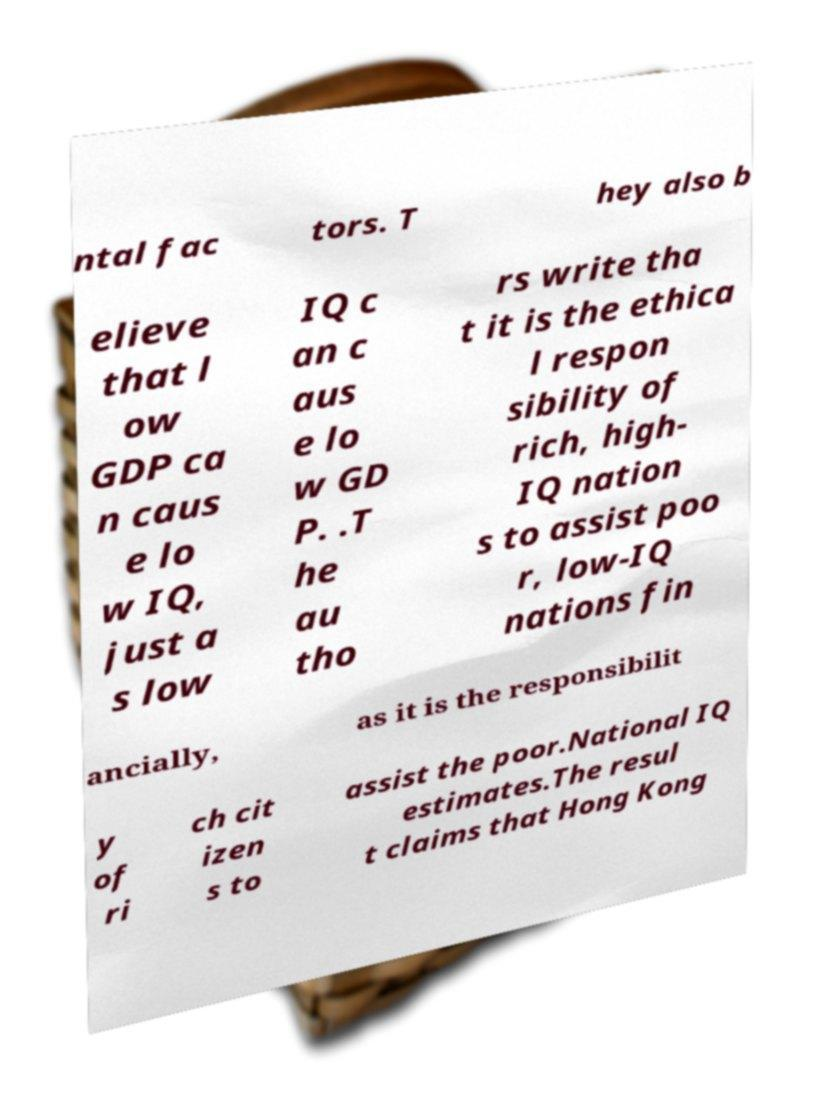Could you extract and type out the text from this image? ntal fac tors. T hey also b elieve that l ow GDP ca n caus e lo w IQ, just a s low IQ c an c aus e lo w GD P. .T he au tho rs write tha t it is the ethica l respon sibility of rich, high- IQ nation s to assist poo r, low-IQ nations fin ancially, as it is the responsibilit y of ri ch cit izen s to assist the poor.National IQ estimates.The resul t claims that Hong Kong 